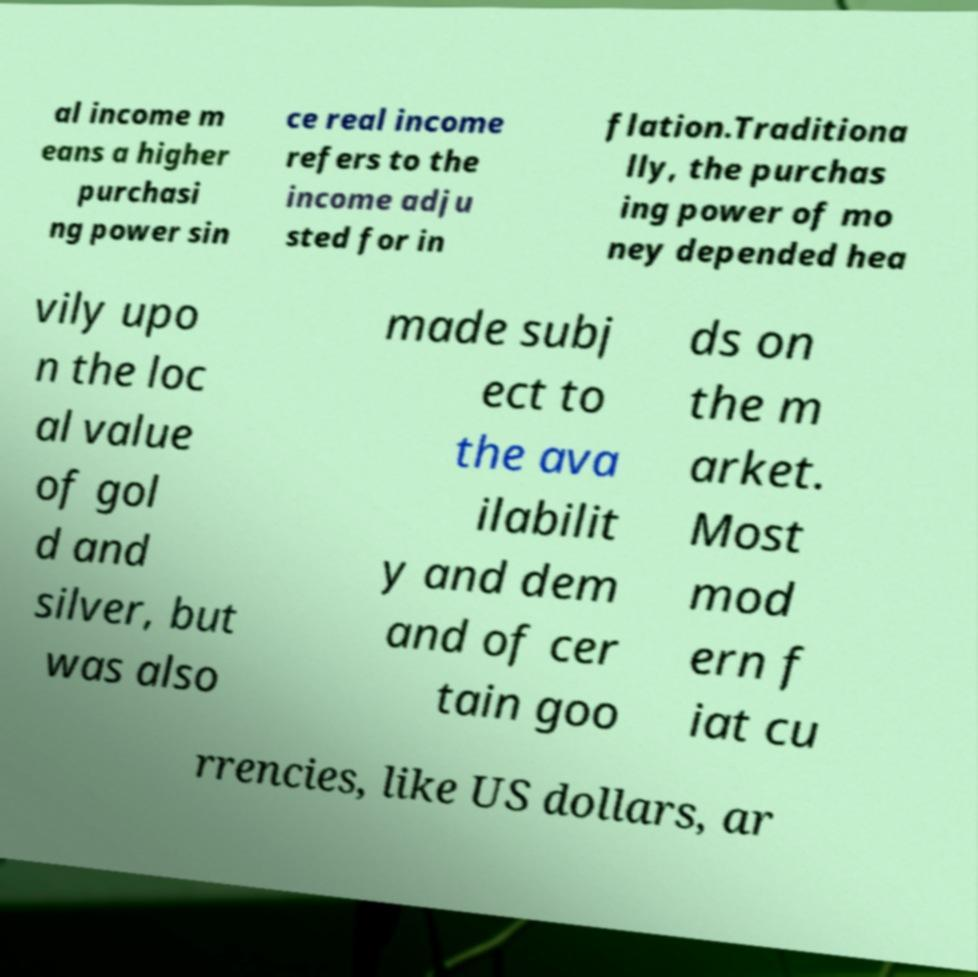Please read and relay the text visible in this image. What does it say? al income m eans a higher purchasi ng power sin ce real income refers to the income adju sted for in flation.Traditiona lly, the purchas ing power of mo ney depended hea vily upo n the loc al value of gol d and silver, but was also made subj ect to the ava ilabilit y and dem and of cer tain goo ds on the m arket. Most mod ern f iat cu rrencies, like US dollars, ar 